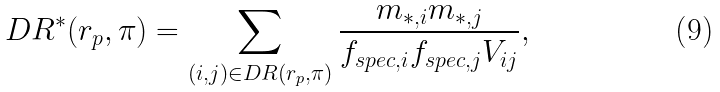<formula> <loc_0><loc_0><loc_500><loc_500>D R ^ { \ast } ( r _ { p } , \pi ) = \sum _ { ( i , j ) \in D R ( r _ { p } , \pi ) } \frac { m _ { \ast , i } m _ { \ast , j } } { f _ { s p e c , i } f _ { s p e c , j } V _ { i j } } ,</formula> 